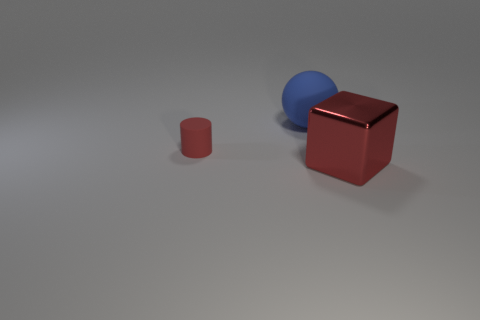Add 2 tiny brown spheres. How many objects exist? 5 Subtract all cylinders. How many objects are left? 2 Add 1 cylinders. How many cylinders exist? 2 Subtract 1 red cylinders. How many objects are left? 2 Subtract all matte cylinders. Subtract all red shiny cubes. How many objects are left? 1 Add 1 red metal things. How many red metal things are left? 2 